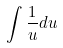<formula> <loc_0><loc_0><loc_500><loc_500>\int \frac { 1 } { u } d u</formula> 